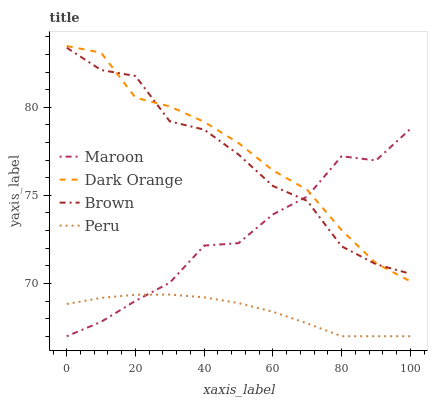Does Peru have the minimum area under the curve?
Answer yes or no. Yes. Does Dark Orange have the maximum area under the curve?
Answer yes or no. Yes. Does Maroon have the minimum area under the curve?
Answer yes or no. No. Does Maroon have the maximum area under the curve?
Answer yes or no. No. Is Peru the smoothest?
Answer yes or no. Yes. Is Maroon the roughest?
Answer yes or no. Yes. Is Maroon the smoothest?
Answer yes or no. No. Is Peru the roughest?
Answer yes or no. No. Does Peru have the lowest value?
Answer yes or no. Yes. Does Brown have the lowest value?
Answer yes or no. No. Does Dark Orange have the highest value?
Answer yes or no. Yes. Does Maroon have the highest value?
Answer yes or no. No. Is Peru less than Dark Orange?
Answer yes or no. Yes. Is Brown greater than Peru?
Answer yes or no. Yes. Does Brown intersect Dark Orange?
Answer yes or no. Yes. Is Brown less than Dark Orange?
Answer yes or no. No. Is Brown greater than Dark Orange?
Answer yes or no. No. Does Peru intersect Dark Orange?
Answer yes or no. No. 